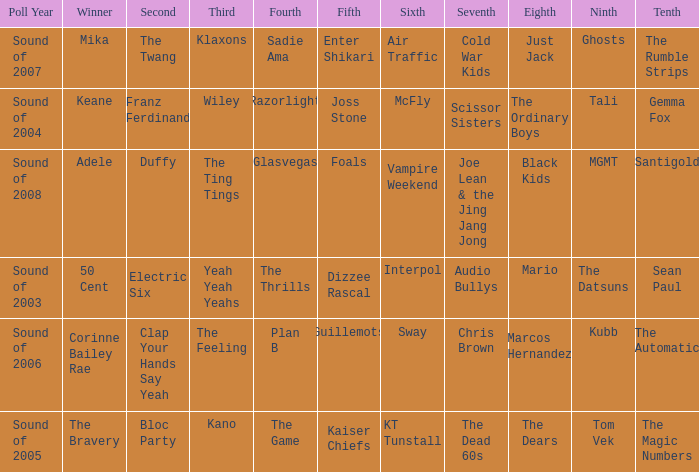Could you parse the entire table as a dict? {'header': ['Poll Year', 'Winner', 'Second', 'Third', 'Fourth', 'Fifth', 'Sixth', 'Seventh', 'Eighth', 'Ninth', 'Tenth'], 'rows': [['Sound of 2007', 'Mika', 'The Twang', 'Klaxons', 'Sadie Ama', 'Enter Shikari', 'Air Traffic', 'Cold War Kids', 'Just Jack', 'Ghosts', 'The Rumble Strips'], ['Sound of 2004', 'Keane', 'Franz Ferdinand', 'Wiley', 'Razorlight', 'Joss Stone', 'McFly', 'Scissor Sisters', 'The Ordinary Boys', 'Tali', 'Gemma Fox'], ['Sound of 2008', 'Adele', 'Duffy', 'The Ting Tings', 'Glasvegas', 'Foals', 'Vampire Weekend', 'Joe Lean & the Jing Jang Jong', 'Black Kids', 'MGMT', 'Santigold'], ['Sound of 2003', '50 Cent', 'Electric Six', 'Yeah Yeah Yeahs', 'The Thrills', 'Dizzee Rascal', 'Interpol', 'Audio Bullys', 'Mario', 'The Datsuns', 'Sean Paul'], ['Sound of 2006', 'Corinne Bailey Rae', 'Clap Your Hands Say Yeah', 'The Feeling', 'Plan B', 'Guillemots', 'Sway', 'Chris Brown', 'Marcos Hernandez', 'Kubb', 'The Automatic'], ['Sound of 2005', 'The Bravery', 'Bloc Party', 'Kano', 'The Game', 'Kaiser Chiefs', 'KT Tunstall', 'The Dead 60s', 'The Dears', 'Tom Vek', 'The Magic Numbers']]} Who was in 4th when in 6th is Air Traffic? Sadie Ama. 